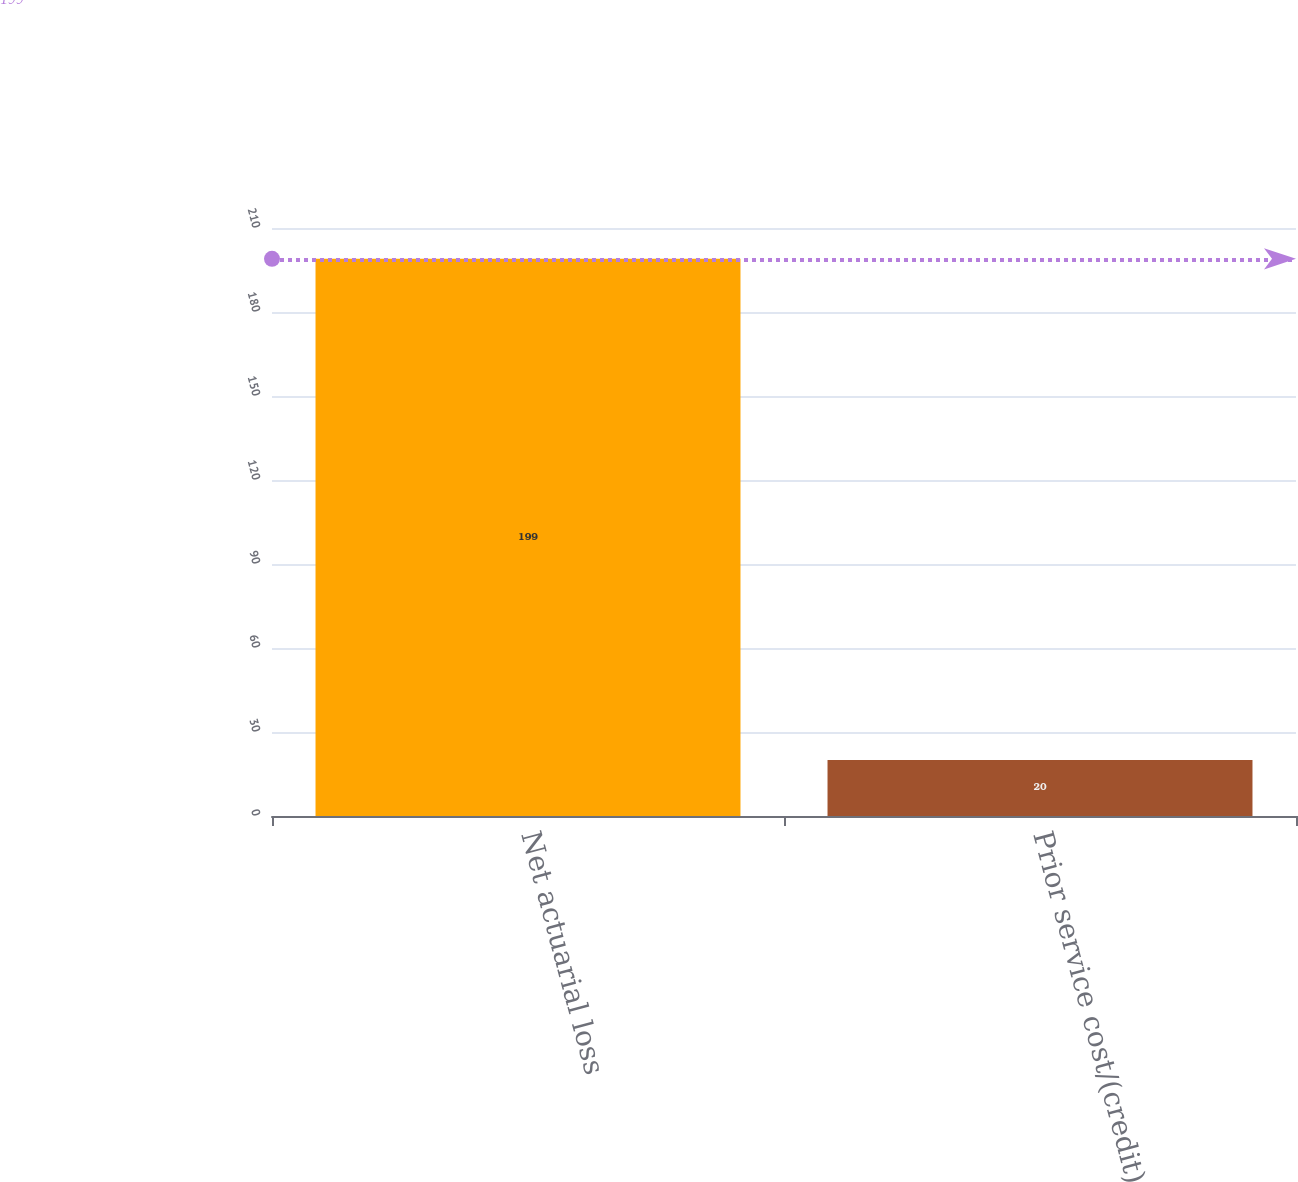Convert chart. <chart><loc_0><loc_0><loc_500><loc_500><bar_chart><fcel>Net actuarial loss<fcel>Prior service cost/(credit)<nl><fcel>199<fcel>20<nl></chart> 